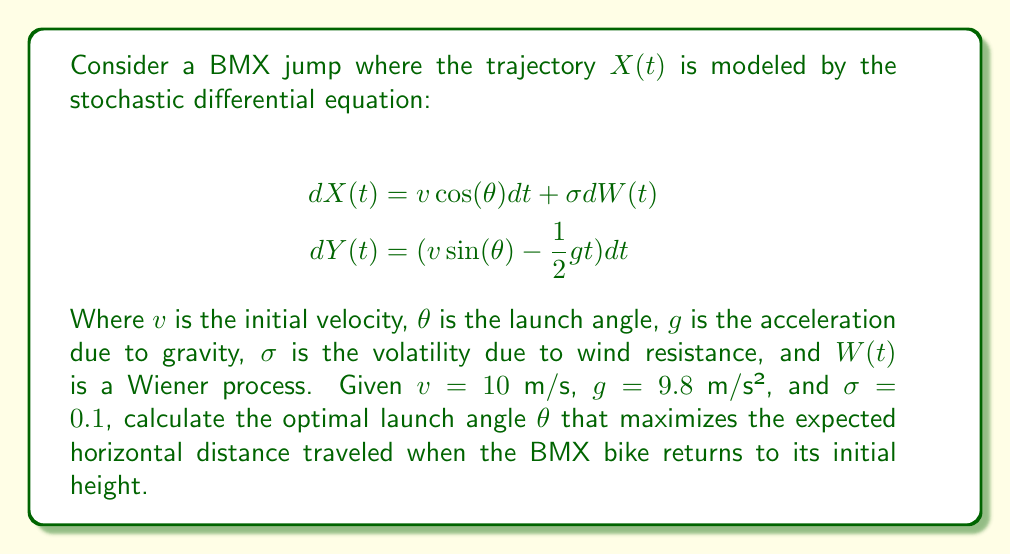Help me with this question. To solve this problem, we'll follow these steps:

1) The expected horizontal distance is given by the solution to the X-component when Y returns to zero. We can ignore the stochastic term for calculating the expected value.

2) The time of flight $T$ can be found by solving $Y(T) = 0$:

   $$0 = v \sin(\theta) T - \frac{1}{2}gT^2$$
   $$T = \frac{2v \sin(\theta)}{g}$$

3) The expected horizontal distance $E[X(T)]$ is then:

   $$E[X(T)] = v \cos(\theta) T = v \cos(\theta) \cdot \frac{2v \sin(\theta)}{g} = \frac{2v^2 \sin(\theta) \cos(\theta)}{g}$$

4) Using the trigonometric identity $\sin(2\theta) = 2\sin(\theta)\cos(\theta)$, we can simplify:

   $$E[X(T)] = \frac{v^2 \sin(2\theta)}{g}$$

5) To find the maximum, we differentiate with respect to $\theta$ and set to zero:

   $$\frac{d}{d\theta}E[X(T)] = \frac{v^2 \cos(2\theta)}{g} = 0$$

6) This is satisfied when $2\theta = 90°$, or $\theta = 45°$.

7) We can confirm this is a maximum by checking the second derivative is negative at this point.

8) Substituting the given values $v = 10$ m/s and $g = 9.8$ m/s² into the expression for $E[X(T)]$:

   $$E[X(T)] = \frac{10^2 \sin(2 \cdot 45°)}{9.8} \approx 10.20 \text{ meters}$$

Note: The volatility $\sigma$ doesn't affect the expected value, but would influence the variance of the actual distance traveled.
Answer: $45°$ 